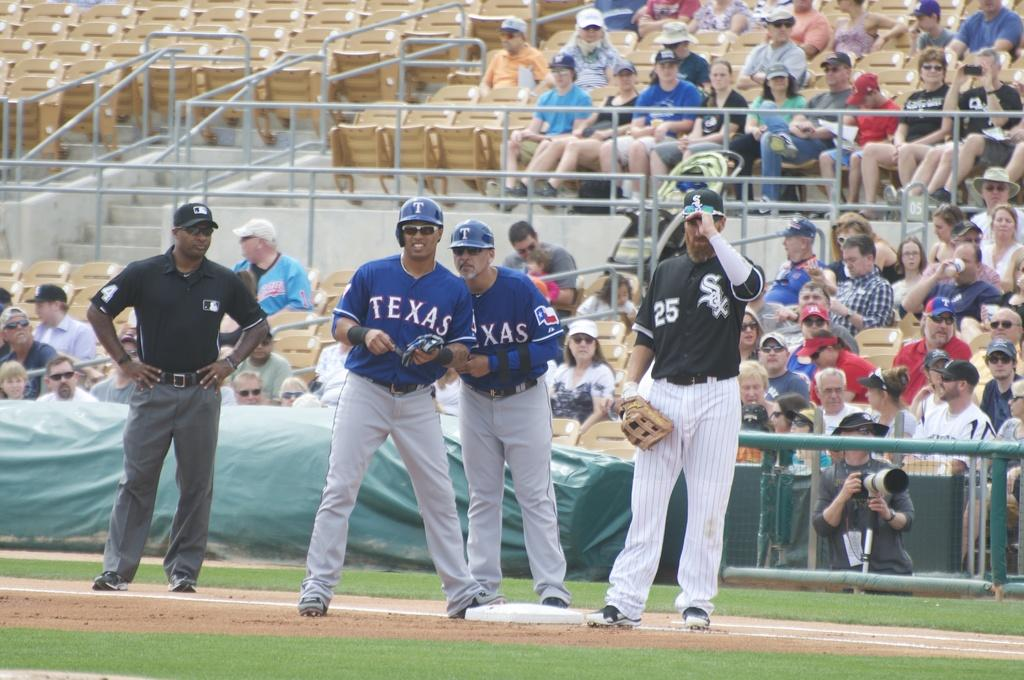<image>
Share a concise interpretation of the image provided. a man from texas team on base listening to his coach 